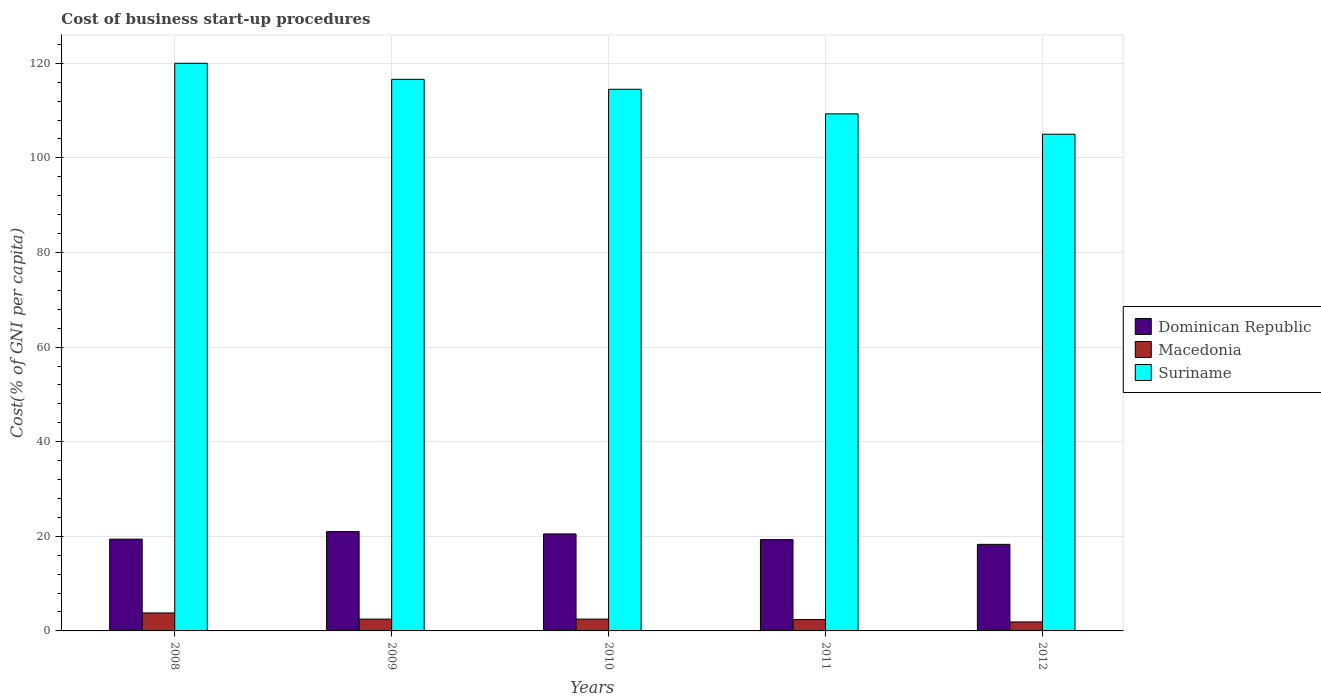How many different coloured bars are there?
Provide a succinct answer. 3. How many bars are there on the 3rd tick from the left?
Offer a terse response. 3. How many bars are there on the 2nd tick from the right?
Your answer should be compact. 3. What is the cost of business start-up procedures in Dominican Republic in 2012?
Offer a terse response. 18.3. Across all years, what is the maximum cost of business start-up procedures in Suriname?
Your answer should be very brief. 120. Across all years, what is the minimum cost of business start-up procedures in Suriname?
Give a very brief answer. 105. What is the total cost of business start-up procedures in Macedonia in the graph?
Your answer should be very brief. 13.1. What is the difference between the cost of business start-up procedures in Macedonia in 2009 and that in 2011?
Offer a very short reply. 0.1. What is the difference between the cost of business start-up procedures in Macedonia in 2008 and the cost of business start-up procedures in Dominican Republic in 2009?
Give a very brief answer. -17.2. What is the average cost of business start-up procedures in Dominican Republic per year?
Provide a succinct answer. 19.7. In the year 2010, what is the difference between the cost of business start-up procedures in Suriname and cost of business start-up procedures in Dominican Republic?
Provide a short and direct response. 94. In how many years, is the cost of business start-up procedures in Dominican Republic greater than 108 %?
Provide a succinct answer. 0. What is the ratio of the cost of business start-up procedures in Suriname in 2010 to that in 2011?
Provide a short and direct response. 1.05. Is the cost of business start-up procedures in Dominican Republic in 2008 less than that in 2011?
Your answer should be very brief. No. Is the difference between the cost of business start-up procedures in Suriname in 2008 and 2011 greater than the difference between the cost of business start-up procedures in Dominican Republic in 2008 and 2011?
Ensure brevity in your answer.  Yes. What is the difference between the highest and the second highest cost of business start-up procedures in Dominican Republic?
Give a very brief answer. 0.5. What is the difference between the highest and the lowest cost of business start-up procedures in Dominican Republic?
Offer a very short reply. 2.7. In how many years, is the cost of business start-up procedures in Suriname greater than the average cost of business start-up procedures in Suriname taken over all years?
Keep it short and to the point. 3. What does the 2nd bar from the left in 2008 represents?
Offer a very short reply. Macedonia. What does the 1st bar from the right in 2011 represents?
Keep it short and to the point. Suriname. Are all the bars in the graph horizontal?
Ensure brevity in your answer.  No. How many years are there in the graph?
Provide a succinct answer. 5. Are the values on the major ticks of Y-axis written in scientific E-notation?
Your answer should be compact. No. Does the graph contain any zero values?
Your answer should be very brief. No. Where does the legend appear in the graph?
Keep it short and to the point. Center right. What is the title of the graph?
Provide a succinct answer. Cost of business start-up procedures. What is the label or title of the Y-axis?
Provide a succinct answer. Cost(% of GNI per capita). What is the Cost(% of GNI per capita) of Suriname in 2008?
Give a very brief answer. 120. What is the Cost(% of GNI per capita) in Dominican Republic in 2009?
Offer a terse response. 21. What is the Cost(% of GNI per capita) in Suriname in 2009?
Your answer should be compact. 116.6. What is the Cost(% of GNI per capita) in Dominican Republic in 2010?
Your answer should be compact. 20.5. What is the Cost(% of GNI per capita) in Macedonia in 2010?
Offer a terse response. 2.5. What is the Cost(% of GNI per capita) of Suriname in 2010?
Ensure brevity in your answer.  114.5. What is the Cost(% of GNI per capita) of Dominican Republic in 2011?
Provide a succinct answer. 19.3. What is the Cost(% of GNI per capita) of Suriname in 2011?
Ensure brevity in your answer.  109.3. What is the Cost(% of GNI per capita) in Suriname in 2012?
Give a very brief answer. 105. Across all years, what is the maximum Cost(% of GNI per capita) in Macedonia?
Make the answer very short. 3.8. Across all years, what is the maximum Cost(% of GNI per capita) of Suriname?
Your answer should be compact. 120. Across all years, what is the minimum Cost(% of GNI per capita) in Dominican Republic?
Make the answer very short. 18.3. Across all years, what is the minimum Cost(% of GNI per capita) of Suriname?
Provide a succinct answer. 105. What is the total Cost(% of GNI per capita) in Dominican Republic in the graph?
Make the answer very short. 98.5. What is the total Cost(% of GNI per capita) of Macedonia in the graph?
Your response must be concise. 13.1. What is the total Cost(% of GNI per capita) of Suriname in the graph?
Keep it short and to the point. 565.4. What is the difference between the Cost(% of GNI per capita) in Macedonia in 2008 and that in 2009?
Offer a terse response. 1.3. What is the difference between the Cost(% of GNI per capita) of Suriname in 2008 and that in 2009?
Provide a succinct answer. 3.4. What is the difference between the Cost(% of GNI per capita) of Dominican Republic in 2008 and that in 2010?
Your answer should be compact. -1.1. What is the difference between the Cost(% of GNI per capita) of Dominican Republic in 2008 and that in 2011?
Your answer should be very brief. 0.1. What is the difference between the Cost(% of GNI per capita) in Suriname in 2008 and that in 2011?
Provide a short and direct response. 10.7. What is the difference between the Cost(% of GNI per capita) in Dominican Republic in 2008 and that in 2012?
Your answer should be very brief. 1.1. What is the difference between the Cost(% of GNI per capita) of Suriname in 2008 and that in 2012?
Your answer should be compact. 15. What is the difference between the Cost(% of GNI per capita) in Macedonia in 2009 and that in 2010?
Your answer should be compact. 0. What is the difference between the Cost(% of GNI per capita) in Dominican Republic in 2009 and that in 2011?
Give a very brief answer. 1.7. What is the difference between the Cost(% of GNI per capita) in Macedonia in 2009 and that in 2011?
Ensure brevity in your answer.  0.1. What is the difference between the Cost(% of GNI per capita) in Suriname in 2009 and that in 2011?
Offer a terse response. 7.3. What is the difference between the Cost(% of GNI per capita) in Macedonia in 2009 and that in 2012?
Your answer should be very brief. 0.6. What is the difference between the Cost(% of GNI per capita) in Suriname in 2011 and that in 2012?
Your response must be concise. 4.3. What is the difference between the Cost(% of GNI per capita) in Dominican Republic in 2008 and the Cost(% of GNI per capita) in Suriname in 2009?
Offer a terse response. -97.2. What is the difference between the Cost(% of GNI per capita) in Macedonia in 2008 and the Cost(% of GNI per capita) in Suriname in 2009?
Offer a very short reply. -112.8. What is the difference between the Cost(% of GNI per capita) of Dominican Republic in 2008 and the Cost(% of GNI per capita) of Macedonia in 2010?
Offer a terse response. 16.9. What is the difference between the Cost(% of GNI per capita) of Dominican Republic in 2008 and the Cost(% of GNI per capita) of Suriname in 2010?
Provide a short and direct response. -95.1. What is the difference between the Cost(% of GNI per capita) of Macedonia in 2008 and the Cost(% of GNI per capita) of Suriname in 2010?
Offer a terse response. -110.7. What is the difference between the Cost(% of GNI per capita) of Dominican Republic in 2008 and the Cost(% of GNI per capita) of Macedonia in 2011?
Give a very brief answer. 17. What is the difference between the Cost(% of GNI per capita) in Dominican Republic in 2008 and the Cost(% of GNI per capita) in Suriname in 2011?
Keep it short and to the point. -89.9. What is the difference between the Cost(% of GNI per capita) of Macedonia in 2008 and the Cost(% of GNI per capita) of Suriname in 2011?
Give a very brief answer. -105.5. What is the difference between the Cost(% of GNI per capita) in Dominican Republic in 2008 and the Cost(% of GNI per capita) in Macedonia in 2012?
Provide a short and direct response. 17.5. What is the difference between the Cost(% of GNI per capita) of Dominican Republic in 2008 and the Cost(% of GNI per capita) of Suriname in 2012?
Keep it short and to the point. -85.6. What is the difference between the Cost(% of GNI per capita) in Macedonia in 2008 and the Cost(% of GNI per capita) in Suriname in 2012?
Provide a succinct answer. -101.2. What is the difference between the Cost(% of GNI per capita) in Dominican Republic in 2009 and the Cost(% of GNI per capita) in Macedonia in 2010?
Offer a terse response. 18.5. What is the difference between the Cost(% of GNI per capita) in Dominican Republic in 2009 and the Cost(% of GNI per capita) in Suriname in 2010?
Keep it short and to the point. -93.5. What is the difference between the Cost(% of GNI per capita) in Macedonia in 2009 and the Cost(% of GNI per capita) in Suriname in 2010?
Ensure brevity in your answer.  -112. What is the difference between the Cost(% of GNI per capita) in Dominican Republic in 2009 and the Cost(% of GNI per capita) in Macedonia in 2011?
Provide a short and direct response. 18.6. What is the difference between the Cost(% of GNI per capita) in Dominican Republic in 2009 and the Cost(% of GNI per capita) in Suriname in 2011?
Keep it short and to the point. -88.3. What is the difference between the Cost(% of GNI per capita) in Macedonia in 2009 and the Cost(% of GNI per capita) in Suriname in 2011?
Offer a terse response. -106.8. What is the difference between the Cost(% of GNI per capita) of Dominican Republic in 2009 and the Cost(% of GNI per capita) of Macedonia in 2012?
Ensure brevity in your answer.  19.1. What is the difference between the Cost(% of GNI per capita) of Dominican Republic in 2009 and the Cost(% of GNI per capita) of Suriname in 2012?
Provide a short and direct response. -84. What is the difference between the Cost(% of GNI per capita) in Macedonia in 2009 and the Cost(% of GNI per capita) in Suriname in 2012?
Provide a succinct answer. -102.5. What is the difference between the Cost(% of GNI per capita) in Dominican Republic in 2010 and the Cost(% of GNI per capita) in Suriname in 2011?
Provide a succinct answer. -88.8. What is the difference between the Cost(% of GNI per capita) in Macedonia in 2010 and the Cost(% of GNI per capita) in Suriname in 2011?
Ensure brevity in your answer.  -106.8. What is the difference between the Cost(% of GNI per capita) of Dominican Republic in 2010 and the Cost(% of GNI per capita) of Macedonia in 2012?
Make the answer very short. 18.6. What is the difference between the Cost(% of GNI per capita) of Dominican Republic in 2010 and the Cost(% of GNI per capita) of Suriname in 2012?
Give a very brief answer. -84.5. What is the difference between the Cost(% of GNI per capita) in Macedonia in 2010 and the Cost(% of GNI per capita) in Suriname in 2012?
Your response must be concise. -102.5. What is the difference between the Cost(% of GNI per capita) in Dominican Republic in 2011 and the Cost(% of GNI per capita) in Suriname in 2012?
Offer a very short reply. -85.7. What is the difference between the Cost(% of GNI per capita) in Macedonia in 2011 and the Cost(% of GNI per capita) in Suriname in 2012?
Make the answer very short. -102.6. What is the average Cost(% of GNI per capita) of Macedonia per year?
Your response must be concise. 2.62. What is the average Cost(% of GNI per capita) in Suriname per year?
Provide a short and direct response. 113.08. In the year 2008, what is the difference between the Cost(% of GNI per capita) in Dominican Republic and Cost(% of GNI per capita) in Macedonia?
Your answer should be very brief. 15.6. In the year 2008, what is the difference between the Cost(% of GNI per capita) in Dominican Republic and Cost(% of GNI per capita) in Suriname?
Offer a very short reply. -100.6. In the year 2008, what is the difference between the Cost(% of GNI per capita) in Macedonia and Cost(% of GNI per capita) in Suriname?
Your response must be concise. -116.2. In the year 2009, what is the difference between the Cost(% of GNI per capita) in Dominican Republic and Cost(% of GNI per capita) in Suriname?
Your answer should be very brief. -95.6. In the year 2009, what is the difference between the Cost(% of GNI per capita) in Macedonia and Cost(% of GNI per capita) in Suriname?
Keep it short and to the point. -114.1. In the year 2010, what is the difference between the Cost(% of GNI per capita) in Dominican Republic and Cost(% of GNI per capita) in Macedonia?
Your answer should be very brief. 18. In the year 2010, what is the difference between the Cost(% of GNI per capita) in Dominican Republic and Cost(% of GNI per capita) in Suriname?
Your response must be concise. -94. In the year 2010, what is the difference between the Cost(% of GNI per capita) of Macedonia and Cost(% of GNI per capita) of Suriname?
Provide a succinct answer. -112. In the year 2011, what is the difference between the Cost(% of GNI per capita) in Dominican Republic and Cost(% of GNI per capita) in Suriname?
Ensure brevity in your answer.  -90. In the year 2011, what is the difference between the Cost(% of GNI per capita) in Macedonia and Cost(% of GNI per capita) in Suriname?
Offer a terse response. -106.9. In the year 2012, what is the difference between the Cost(% of GNI per capita) of Dominican Republic and Cost(% of GNI per capita) of Suriname?
Make the answer very short. -86.7. In the year 2012, what is the difference between the Cost(% of GNI per capita) in Macedonia and Cost(% of GNI per capita) in Suriname?
Your answer should be compact. -103.1. What is the ratio of the Cost(% of GNI per capita) of Dominican Republic in 2008 to that in 2009?
Your response must be concise. 0.92. What is the ratio of the Cost(% of GNI per capita) in Macedonia in 2008 to that in 2009?
Provide a short and direct response. 1.52. What is the ratio of the Cost(% of GNI per capita) of Suriname in 2008 to that in 2009?
Provide a succinct answer. 1.03. What is the ratio of the Cost(% of GNI per capita) of Dominican Republic in 2008 to that in 2010?
Give a very brief answer. 0.95. What is the ratio of the Cost(% of GNI per capita) in Macedonia in 2008 to that in 2010?
Provide a succinct answer. 1.52. What is the ratio of the Cost(% of GNI per capita) of Suriname in 2008 to that in 2010?
Keep it short and to the point. 1.05. What is the ratio of the Cost(% of GNI per capita) of Dominican Republic in 2008 to that in 2011?
Offer a terse response. 1.01. What is the ratio of the Cost(% of GNI per capita) of Macedonia in 2008 to that in 2011?
Make the answer very short. 1.58. What is the ratio of the Cost(% of GNI per capita) in Suriname in 2008 to that in 2011?
Keep it short and to the point. 1.1. What is the ratio of the Cost(% of GNI per capita) in Dominican Republic in 2008 to that in 2012?
Provide a succinct answer. 1.06. What is the ratio of the Cost(% of GNI per capita) in Macedonia in 2008 to that in 2012?
Give a very brief answer. 2. What is the ratio of the Cost(% of GNI per capita) of Dominican Republic in 2009 to that in 2010?
Your answer should be compact. 1.02. What is the ratio of the Cost(% of GNI per capita) of Macedonia in 2009 to that in 2010?
Provide a succinct answer. 1. What is the ratio of the Cost(% of GNI per capita) in Suriname in 2009 to that in 2010?
Give a very brief answer. 1.02. What is the ratio of the Cost(% of GNI per capita) of Dominican Republic in 2009 to that in 2011?
Provide a short and direct response. 1.09. What is the ratio of the Cost(% of GNI per capita) of Macedonia in 2009 to that in 2011?
Keep it short and to the point. 1.04. What is the ratio of the Cost(% of GNI per capita) of Suriname in 2009 to that in 2011?
Offer a terse response. 1.07. What is the ratio of the Cost(% of GNI per capita) in Dominican Republic in 2009 to that in 2012?
Make the answer very short. 1.15. What is the ratio of the Cost(% of GNI per capita) in Macedonia in 2009 to that in 2012?
Offer a very short reply. 1.32. What is the ratio of the Cost(% of GNI per capita) in Suriname in 2009 to that in 2012?
Ensure brevity in your answer.  1.11. What is the ratio of the Cost(% of GNI per capita) in Dominican Republic in 2010 to that in 2011?
Your answer should be very brief. 1.06. What is the ratio of the Cost(% of GNI per capita) of Macedonia in 2010 to that in 2011?
Your response must be concise. 1.04. What is the ratio of the Cost(% of GNI per capita) in Suriname in 2010 to that in 2011?
Make the answer very short. 1.05. What is the ratio of the Cost(% of GNI per capita) of Dominican Republic in 2010 to that in 2012?
Provide a short and direct response. 1.12. What is the ratio of the Cost(% of GNI per capita) in Macedonia in 2010 to that in 2012?
Make the answer very short. 1.32. What is the ratio of the Cost(% of GNI per capita) in Suriname in 2010 to that in 2012?
Your answer should be compact. 1.09. What is the ratio of the Cost(% of GNI per capita) of Dominican Republic in 2011 to that in 2012?
Keep it short and to the point. 1.05. What is the ratio of the Cost(% of GNI per capita) in Macedonia in 2011 to that in 2012?
Your answer should be compact. 1.26. What is the ratio of the Cost(% of GNI per capita) of Suriname in 2011 to that in 2012?
Give a very brief answer. 1.04. What is the difference between the highest and the second highest Cost(% of GNI per capita) of Macedonia?
Your answer should be compact. 1.3. 